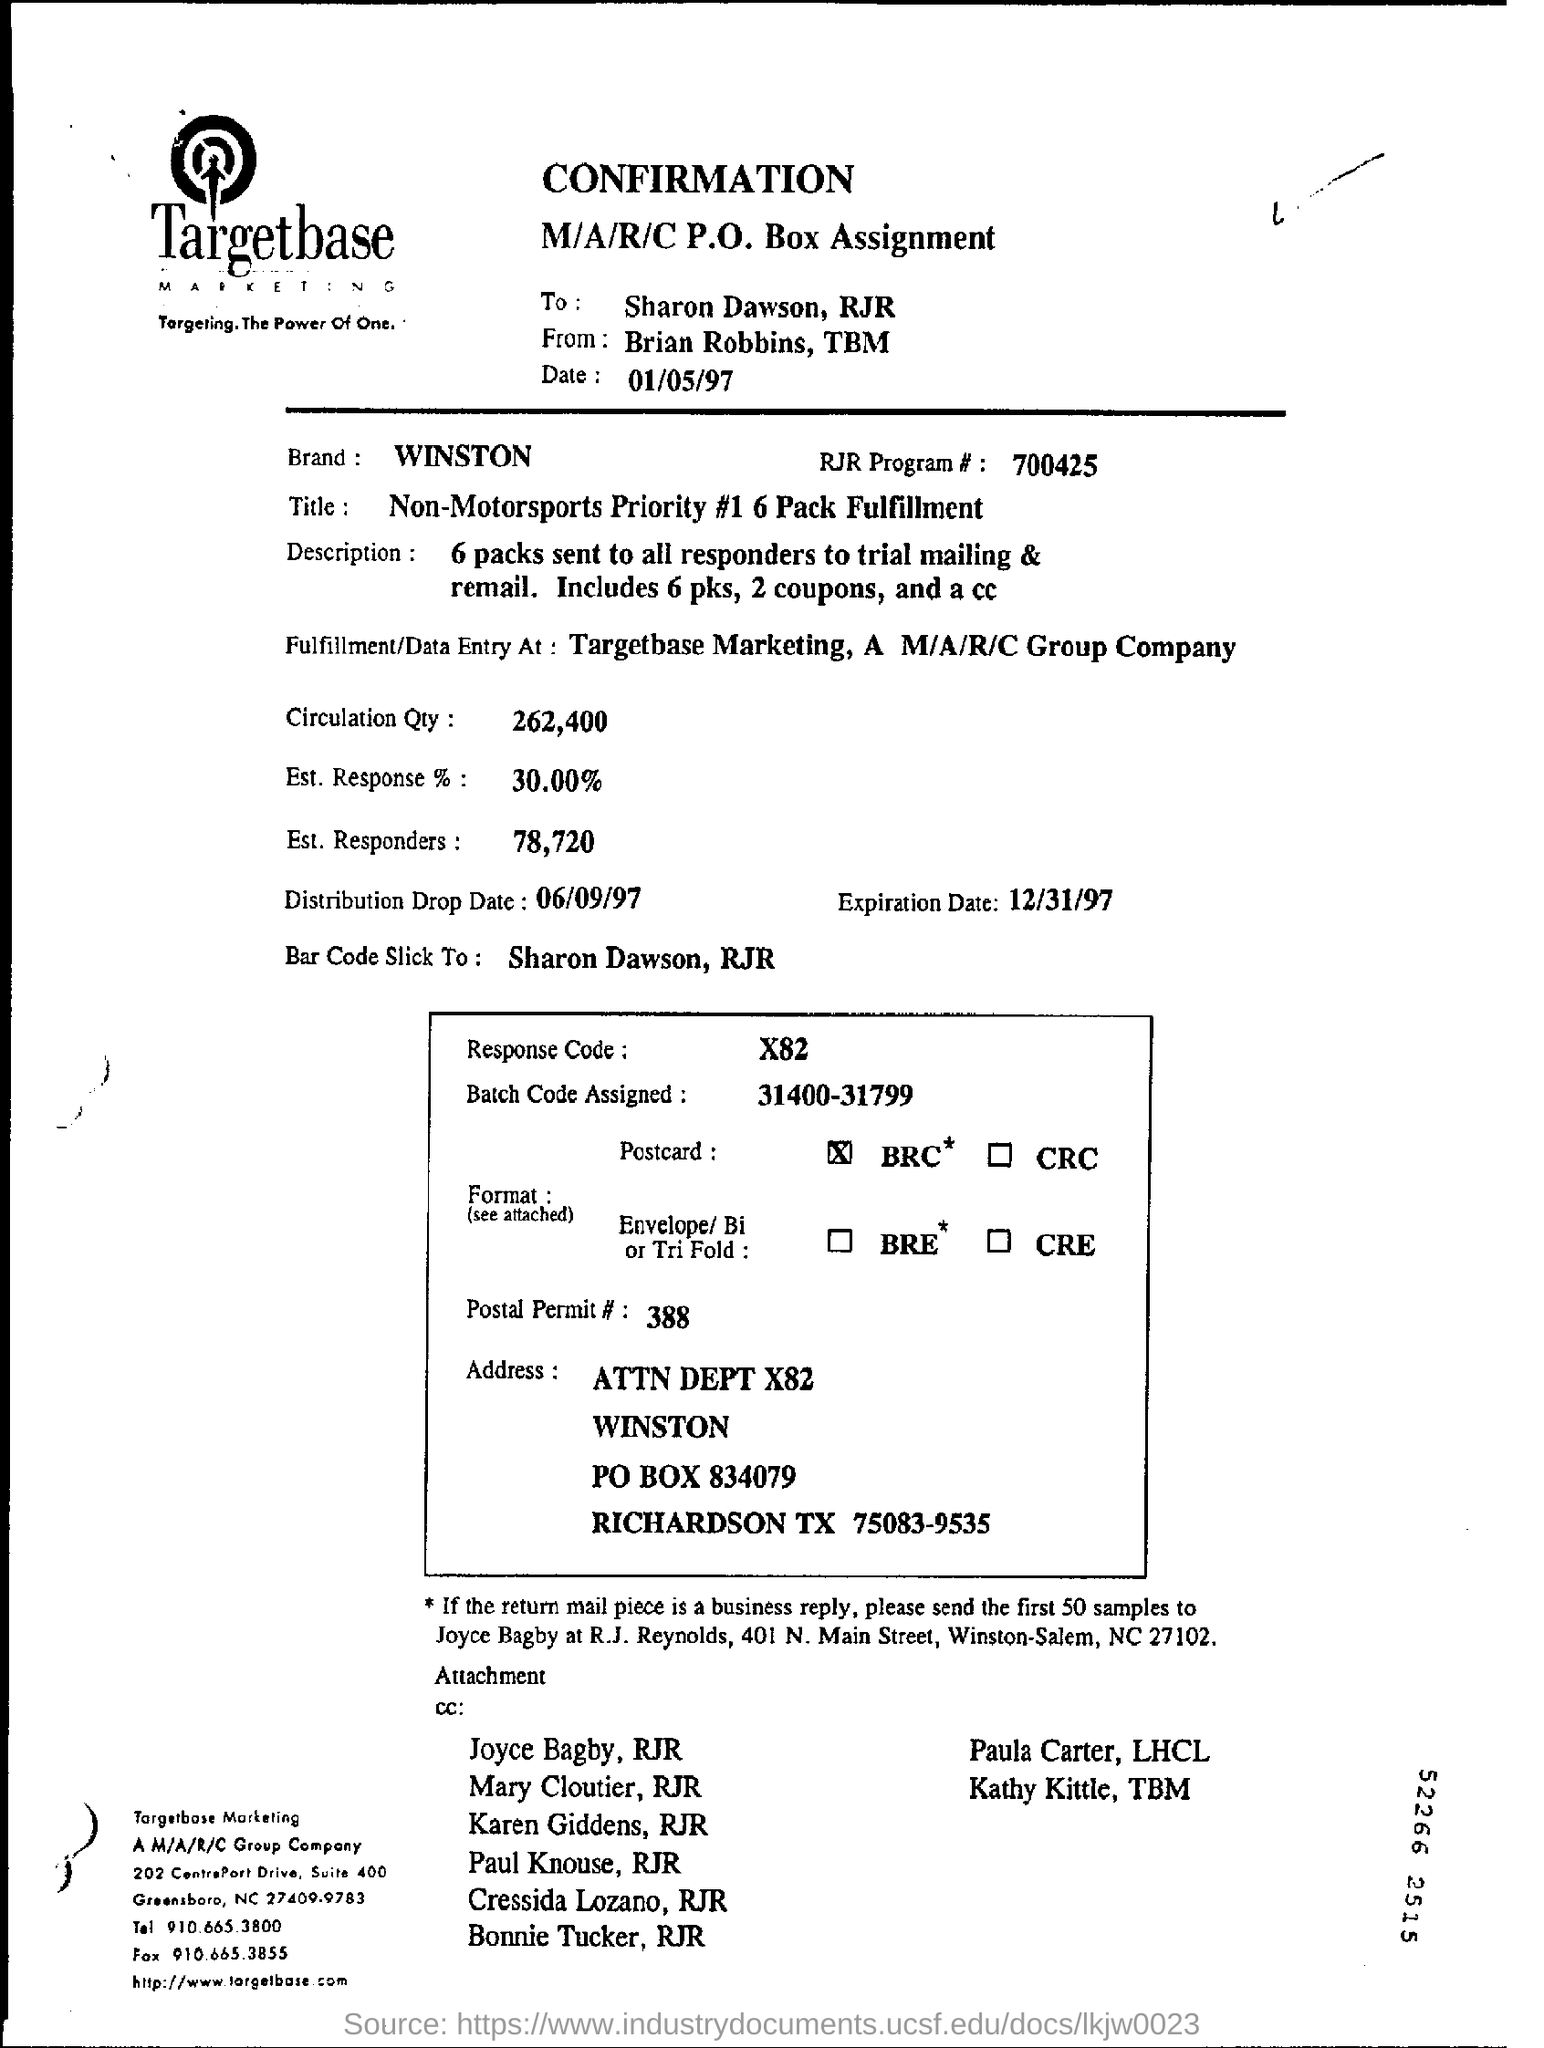Specify some key components in this picture. The expiration date is December 31, 1997. The distribution drop date is September 6, 1997. The response code is X82. The brand name is WINSTON. Out of the estimated 78,720 individuals, 78,720 (100%) were responders. 